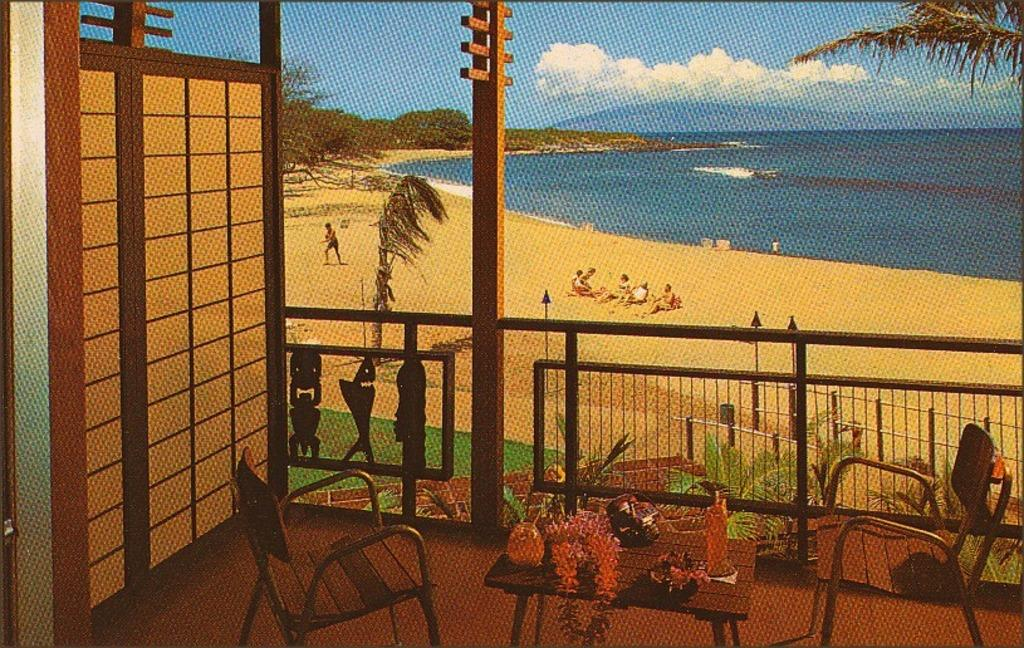What type of structure is visible in the image? There is a grille in the image. What type of furniture is present in the image? There is a table and chairs in the image. What type of natural elements can be seen in the image? There are trees, plants, and water visible in the image. Are there any living beings in the image? Yes, there are people in the image. What is the weather like in the image? The sky is cloudy in the image. What is on the table in the image? There are objects on the table in the image. What type of animals can be seen in the zoo in the image? There is no zoo present in the image, so it is not possible to answer that question. 